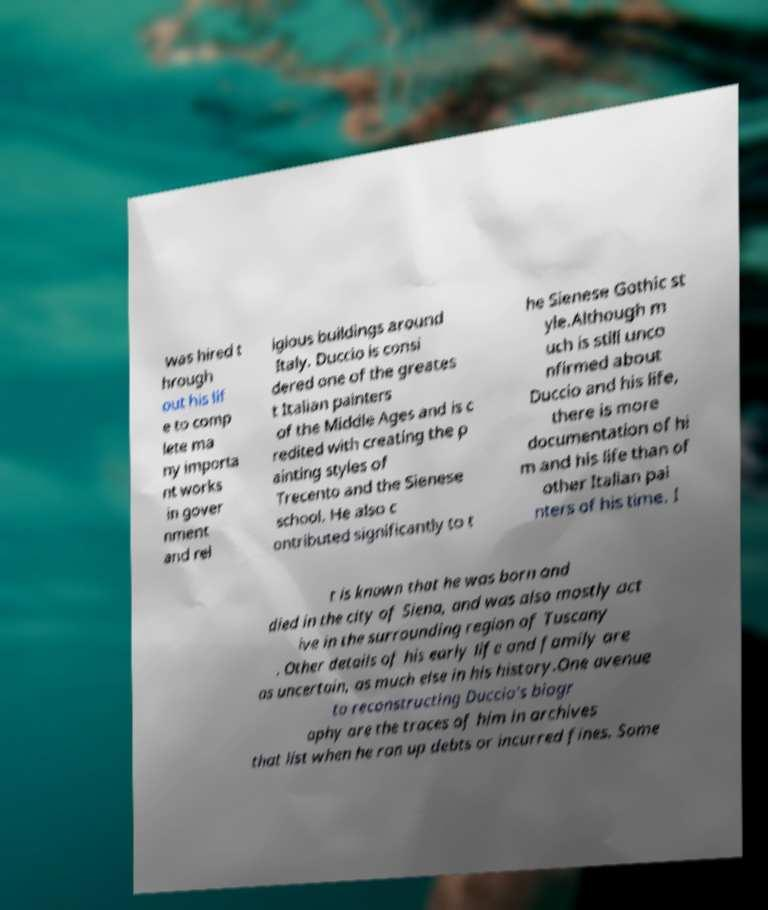For documentation purposes, I need the text within this image transcribed. Could you provide that? was hired t hrough out his lif e to comp lete ma ny importa nt works in gover nment and rel igious buildings around Italy. Duccio is consi dered one of the greates t Italian painters of the Middle Ages and is c redited with creating the p ainting styles of Trecento and the Sienese school. He also c ontributed significantly to t he Sienese Gothic st yle.Although m uch is still unco nfirmed about Duccio and his life, there is more documentation of hi m and his life than of other Italian pai nters of his time. I t is known that he was born and died in the city of Siena, and was also mostly act ive in the surrounding region of Tuscany . Other details of his early life and family are as uncertain, as much else in his history.One avenue to reconstructing Duccio's biogr aphy are the traces of him in archives that list when he ran up debts or incurred fines. Some 